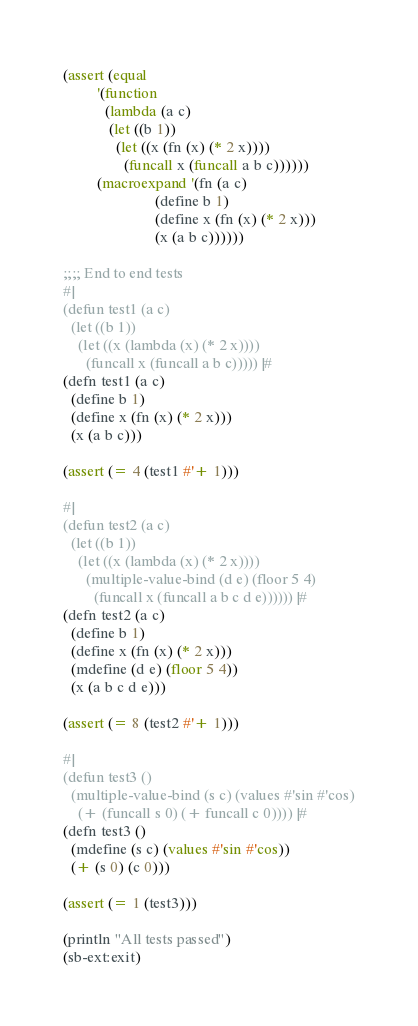<code> <loc_0><loc_0><loc_500><loc_500><_Lisp_>
(assert (equal
         '(function
           (lambda (a c)
            (let ((b 1))
              (let ((x (fn (x) (* 2 x))))
                (funcall x (funcall a b c))))))
         (macroexpand '(fn (a c)
                        (define b 1)
                        (define x (fn (x) (* 2 x)))
                        (x (a b c))))))

;;;; End to end tests
#|
(defun test1 (a c)
  (let ((b 1))
    (let ((x (lambda (x) (* 2 x))))
      (funcall x (funcall a b c))))) |#
(defn test1 (a c)
  (define b 1)
  (define x (fn (x) (* 2 x)))
  (x (a b c)))

(assert (= 4 (test1 #'+ 1)))

#|
(defun test2 (a c)
  (let ((b 1))
    (let ((x (lambda (x) (* 2 x))))
      (multiple-value-bind (d e) (floor 5 4)
        (funcall x (funcall a b c d e)))))) |#
(defn test2 (a c)
  (define b 1)
  (define x (fn (x) (* 2 x)))
  (mdefine (d e) (floor 5 4))
  (x (a b c d e)))

(assert (= 8 (test2 #'+ 1)))

#|
(defun test3 ()
  (multiple-value-bind (s c) (values #'sin #'cos)
    (+ (funcall s 0) (+ funcall c 0)))) |#
(defn test3 ()
  (mdefine (s c) (values #'sin #'cos))
  (+ (s 0) (c 0)))

(assert (= 1 (test3)))

(println "All tests passed")
(sb-ext:exit)
</code> 